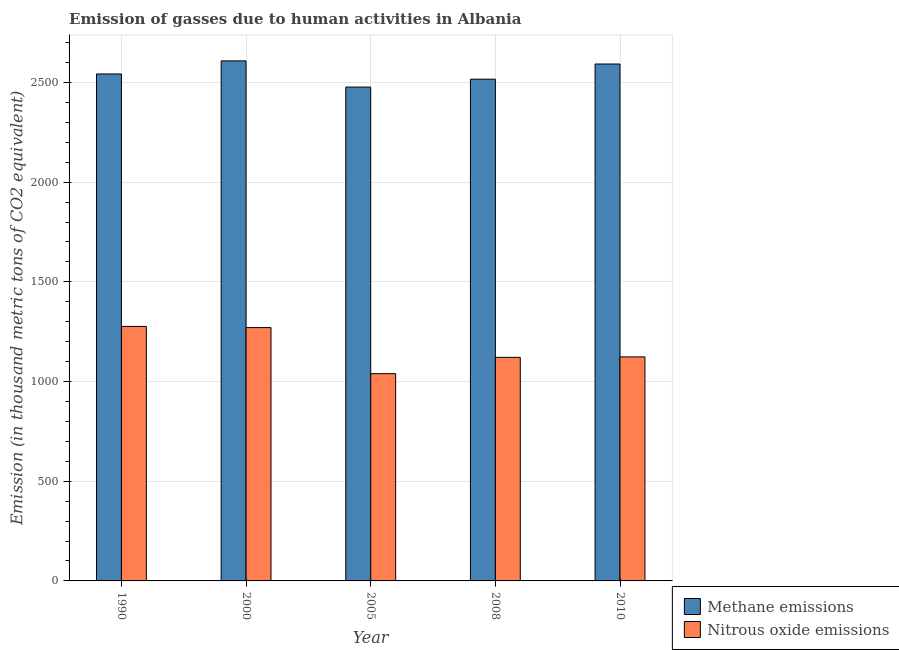How many different coloured bars are there?
Your answer should be very brief. 2. How many groups of bars are there?
Keep it short and to the point. 5. How many bars are there on the 3rd tick from the right?
Make the answer very short. 2. What is the label of the 5th group of bars from the left?
Provide a short and direct response. 2010. What is the amount of methane emissions in 2010?
Provide a succinct answer. 2592.7. Across all years, what is the maximum amount of nitrous oxide emissions?
Make the answer very short. 1276.4. Across all years, what is the minimum amount of methane emissions?
Offer a very short reply. 2477.1. In which year was the amount of methane emissions maximum?
Provide a short and direct response. 2000. In which year was the amount of methane emissions minimum?
Ensure brevity in your answer.  2005. What is the total amount of methane emissions in the graph?
Offer a terse response. 1.27e+04. What is the difference between the amount of methane emissions in 2005 and that in 2010?
Your answer should be very brief. -115.6. What is the difference between the amount of nitrous oxide emissions in 2000 and the amount of methane emissions in 2005?
Provide a succinct answer. 231.1. What is the average amount of nitrous oxide emissions per year?
Offer a very short reply. 1166.34. In the year 2008, what is the difference between the amount of methane emissions and amount of nitrous oxide emissions?
Offer a very short reply. 0. What is the ratio of the amount of nitrous oxide emissions in 1990 to that in 2010?
Ensure brevity in your answer.  1.14. Is the amount of nitrous oxide emissions in 2000 less than that in 2008?
Offer a very short reply. No. Is the difference between the amount of methane emissions in 2008 and 2010 greater than the difference between the amount of nitrous oxide emissions in 2008 and 2010?
Provide a short and direct response. No. What is the difference between the highest and the second highest amount of methane emissions?
Offer a very short reply. 15.7. What is the difference between the highest and the lowest amount of methane emissions?
Ensure brevity in your answer.  131.3. In how many years, is the amount of nitrous oxide emissions greater than the average amount of nitrous oxide emissions taken over all years?
Ensure brevity in your answer.  2. Is the sum of the amount of nitrous oxide emissions in 1990 and 2005 greater than the maximum amount of methane emissions across all years?
Offer a terse response. Yes. What does the 1st bar from the left in 1990 represents?
Ensure brevity in your answer.  Methane emissions. What does the 2nd bar from the right in 2010 represents?
Offer a terse response. Methane emissions. How many bars are there?
Give a very brief answer. 10. Are the values on the major ticks of Y-axis written in scientific E-notation?
Provide a succinct answer. No. Does the graph contain any zero values?
Your answer should be compact. No. Where does the legend appear in the graph?
Your answer should be compact. Bottom right. How many legend labels are there?
Ensure brevity in your answer.  2. What is the title of the graph?
Make the answer very short. Emission of gasses due to human activities in Albania. Does "Automatic Teller Machines" appear as one of the legend labels in the graph?
Offer a terse response. No. What is the label or title of the X-axis?
Keep it short and to the point. Year. What is the label or title of the Y-axis?
Provide a short and direct response. Emission (in thousand metric tons of CO2 equivalent). What is the Emission (in thousand metric tons of CO2 equivalent) in Methane emissions in 1990?
Offer a very short reply. 2542.8. What is the Emission (in thousand metric tons of CO2 equivalent) in Nitrous oxide emissions in 1990?
Your response must be concise. 1276.4. What is the Emission (in thousand metric tons of CO2 equivalent) of Methane emissions in 2000?
Your response must be concise. 2608.4. What is the Emission (in thousand metric tons of CO2 equivalent) of Nitrous oxide emissions in 2000?
Offer a terse response. 1270.7. What is the Emission (in thousand metric tons of CO2 equivalent) of Methane emissions in 2005?
Offer a terse response. 2477.1. What is the Emission (in thousand metric tons of CO2 equivalent) of Nitrous oxide emissions in 2005?
Provide a succinct answer. 1039.6. What is the Emission (in thousand metric tons of CO2 equivalent) of Methane emissions in 2008?
Your answer should be very brief. 2516.7. What is the Emission (in thousand metric tons of CO2 equivalent) of Nitrous oxide emissions in 2008?
Make the answer very short. 1121.4. What is the Emission (in thousand metric tons of CO2 equivalent) of Methane emissions in 2010?
Provide a short and direct response. 2592.7. What is the Emission (in thousand metric tons of CO2 equivalent) in Nitrous oxide emissions in 2010?
Your answer should be very brief. 1123.6. Across all years, what is the maximum Emission (in thousand metric tons of CO2 equivalent) in Methane emissions?
Your answer should be very brief. 2608.4. Across all years, what is the maximum Emission (in thousand metric tons of CO2 equivalent) in Nitrous oxide emissions?
Your answer should be very brief. 1276.4. Across all years, what is the minimum Emission (in thousand metric tons of CO2 equivalent) of Methane emissions?
Offer a terse response. 2477.1. Across all years, what is the minimum Emission (in thousand metric tons of CO2 equivalent) in Nitrous oxide emissions?
Your response must be concise. 1039.6. What is the total Emission (in thousand metric tons of CO2 equivalent) in Methane emissions in the graph?
Give a very brief answer. 1.27e+04. What is the total Emission (in thousand metric tons of CO2 equivalent) of Nitrous oxide emissions in the graph?
Your response must be concise. 5831.7. What is the difference between the Emission (in thousand metric tons of CO2 equivalent) in Methane emissions in 1990 and that in 2000?
Offer a very short reply. -65.6. What is the difference between the Emission (in thousand metric tons of CO2 equivalent) of Methane emissions in 1990 and that in 2005?
Your answer should be very brief. 65.7. What is the difference between the Emission (in thousand metric tons of CO2 equivalent) of Nitrous oxide emissions in 1990 and that in 2005?
Offer a terse response. 236.8. What is the difference between the Emission (in thousand metric tons of CO2 equivalent) in Methane emissions in 1990 and that in 2008?
Keep it short and to the point. 26.1. What is the difference between the Emission (in thousand metric tons of CO2 equivalent) in Nitrous oxide emissions in 1990 and that in 2008?
Ensure brevity in your answer.  155. What is the difference between the Emission (in thousand metric tons of CO2 equivalent) of Methane emissions in 1990 and that in 2010?
Offer a very short reply. -49.9. What is the difference between the Emission (in thousand metric tons of CO2 equivalent) in Nitrous oxide emissions in 1990 and that in 2010?
Your answer should be very brief. 152.8. What is the difference between the Emission (in thousand metric tons of CO2 equivalent) of Methane emissions in 2000 and that in 2005?
Your answer should be compact. 131.3. What is the difference between the Emission (in thousand metric tons of CO2 equivalent) of Nitrous oxide emissions in 2000 and that in 2005?
Keep it short and to the point. 231.1. What is the difference between the Emission (in thousand metric tons of CO2 equivalent) in Methane emissions in 2000 and that in 2008?
Your answer should be very brief. 91.7. What is the difference between the Emission (in thousand metric tons of CO2 equivalent) in Nitrous oxide emissions in 2000 and that in 2008?
Your response must be concise. 149.3. What is the difference between the Emission (in thousand metric tons of CO2 equivalent) of Methane emissions in 2000 and that in 2010?
Make the answer very short. 15.7. What is the difference between the Emission (in thousand metric tons of CO2 equivalent) in Nitrous oxide emissions in 2000 and that in 2010?
Offer a terse response. 147.1. What is the difference between the Emission (in thousand metric tons of CO2 equivalent) in Methane emissions in 2005 and that in 2008?
Offer a very short reply. -39.6. What is the difference between the Emission (in thousand metric tons of CO2 equivalent) of Nitrous oxide emissions in 2005 and that in 2008?
Your answer should be compact. -81.8. What is the difference between the Emission (in thousand metric tons of CO2 equivalent) of Methane emissions in 2005 and that in 2010?
Provide a succinct answer. -115.6. What is the difference between the Emission (in thousand metric tons of CO2 equivalent) of Nitrous oxide emissions in 2005 and that in 2010?
Ensure brevity in your answer.  -84. What is the difference between the Emission (in thousand metric tons of CO2 equivalent) of Methane emissions in 2008 and that in 2010?
Make the answer very short. -76. What is the difference between the Emission (in thousand metric tons of CO2 equivalent) in Nitrous oxide emissions in 2008 and that in 2010?
Provide a short and direct response. -2.2. What is the difference between the Emission (in thousand metric tons of CO2 equivalent) of Methane emissions in 1990 and the Emission (in thousand metric tons of CO2 equivalent) of Nitrous oxide emissions in 2000?
Your response must be concise. 1272.1. What is the difference between the Emission (in thousand metric tons of CO2 equivalent) in Methane emissions in 1990 and the Emission (in thousand metric tons of CO2 equivalent) in Nitrous oxide emissions in 2005?
Your answer should be compact. 1503.2. What is the difference between the Emission (in thousand metric tons of CO2 equivalent) of Methane emissions in 1990 and the Emission (in thousand metric tons of CO2 equivalent) of Nitrous oxide emissions in 2008?
Ensure brevity in your answer.  1421.4. What is the difference between the Emission (in thousand metric tons of CO2 equivalent) of Methane emissions in 1990 and the Emission (in thousand metric tons of CO2 equivalent) of Nitrous oxide emissions in 2010?
Your answer should be very brief. 1419.2. What is the difference between the Emission (in thousand metric tons of CO2 equivalent) of Methane emissions in 2000 and the Emission (in thousand metric tons of CO2 equivalent) of Nitrous oxide emissions in 2005?
Keep it short and to the point. 1568.8. What is the difference between the Emission (in thousand metric tons of CO2 equivalent) of Methane emissions in 2000 and the Emission (in thousand metric tons of CO2 equivalent) of Nitrous oxide emissions in 2008?
Your answer should be compact. 1487. What is the difference between the Emission (in thousand metric tons of CO2 equivalent) in Methane emissions in 2000 and the Emission (in thousand metric tons of CO2 equivalent) in Nitrous oxide emissions in 2010?
Your response must be concise. 1484.8. What is the difference between the Emission (in thousand metric tons of CO2 equivalent) of Methane emissions in 2005 and the Emission (in thousand metric tons of CO2 equivalent) of Nitrous oxide emissions in 2008?
Provide a succinct answer. 1355.7. What is the difference between the Emission (in thousand metric tons of CO2 equivalent) in Methane emissions in 2005 and the Emission (in thousand metric tons of CO2 equivalent) in Nitrous oxide emissions in 2010?
Provide a short and direct response. 1353.5. What is the difference between the Emission (in thousand metric tons of CO2 equivalent) in Methane emissions in 2008 and the Emission (in thousand metric tons of CO2 equivalent) in Nitrous oxide emissions in 2010?
Your answer should be compact. 1393.1. What is the average Emission (in thousand metric tons of CO2 equivalent) of Methane emissions per year?
Provide a short and direct response. 2547.54. What is the average Emission (in thousand metric tons of CO2 equivalent) in Nitrous oxide emissions per year?
Provide a short and direct response. 1166.34. In the year 1990, what is the difference between the Emission (in thousand metric tons of CO2 equivalent) in Methane emissions and Emission (in thousand metric tons of CO2 equivalent) in Nitrous oxide emissions?
Give a very brief answer. 1266.4. In the year 2000, what is the difference between the Emission (in thousand metric tons of CO2 equivalent) of Methane emissions and Emission (in thousand metric tons of CO2 equivalent) of Nitrous oxide emissions?
Provide a short and direct response. 1337.7. In the year 2005, what is the difference between the Emission (in thousand metric tons of CO2 equivalent) in Methane emissions and Emission (in thousand metric tons of CO2 equivalent) in Nitrous oxide emissions?
Provide a succinct answer. 1437.5. In the year 2008, what is the difference between the Emission (in thousand metric tons of CO2 equivalent) of Methane emissions and Emission (in thousand metric tons of CO2 equivalent) of Nitrous oxide emissions?
Your answer should be compact. 1395.3. In the year 2010, what is the difference between the Emission (in thousand metric tons of CO2 equivalent) of Methane emissions and Emission (in thousand metric tons of CO2 equivalent) of Nitrous oxide emissions?
Keep it short and to the point. 1469.1. What is the ratio of the Emission (in thousand metric tons of CO2 equivalent) in Methane emissions in 1990 to that in 2000?
Your answer should be compact. 0.97. What is the ratio of the Emission (in thousand metric tons of CO2 equivalent) in Methane emissions in 1990 to that in 2005?
Provide a short and direct response. 1.03. What is the ratio of the Emission (in thousand metric tons of CO2 equivalent) of Nitrous oxide emissions in 1990 to that in 2005?
Ensure brevity in your answer.  1.23. What is the ratio of the Emission (in thousand metric tons of CO2 equivalent) of Methane emissions in 1990 to that in 2008?
Provide a succinct answer. 1.01. What is the ratio of the Emission (in thousand metric tons of CO2 equivalent) in Nitrous oxide emissions in 1990 to that in 2008?
Provide a succinct answer. 1.14. What is the ratio of the Emission (in thousand metric tons of CO2 equivalent) of Methane emissions in 1990 to that in 2010?
Ensure brevity in your answer.  0.98. What is the ratio of the Emission (in thousand metric tons of CO2 equivalent) in Nitrous oxide emissions in 1990 to that in 2010?
Give a very brief answer. 1.14. What is the ratio of the Emission (in thousand metric tons of CO2 equivalent) of Methane emissions in 2000 to that in 2005?
Give a very brief answer. 1.05. What is the ratio of the Emission (in thousand metric tons of CO2 equivalent) of Nitrous oxide emissions in 2000 to that in 2005?
Offer a terse response. 1.22. What is the ratio of the Emission (in thousand metric tons of CO2 equivalent) in Methane emissions in 2000 to that in 2008?
Provide a succinct answer. 1.04. What is the ratio of the Emission (in thousand metric tons of CO2 equivalent) in Nitrous oxide emissions in 2000 to that in 2008?
Ensure brevity in your answer.  1.13. What is the ratio of the Emission (in thousand metric tons of CO2 equivalent) of Methane emissions in 2000 to that in 2010?
Your answer should be compact. 1.01. What is the ratio of the Emission (in thousand metric tons of CO2 equivalent) in Nitrous oxide emissions in 2000 to that in 2010?
Provide a short and direct response. 1.13. What is the ratio of the Emission (in thousand metric tons of CO2 equivalent) of Methane emissions in 2005 to that in 2008?
Your answer should be compact. 0.98. What is the ratio of the Emission (in thousand metric tons of CO2 equivalent) of Nitrous oxide emissions in 2005 to that in 2008?
Make the answer very short. 0.93. What is the ratio of the Emission (in thousand metric tons of CO2 equivalent) in Methane emissions in 2005 to that in 2010?
Give a very brief answer. 0.96. What is the ratio of the Emission (in thousand metric tons of CO2 equivalent) in Nitrous oxide emissions in 2005 to that in 2010?
Provide a succinct answer. 0.93. What is the ratio of the Emission (in thousand metric tons of CO2 equivalent) in Methane emissions in 2008 to that in 2010?
Provide a succinct answer. 0.97. What is the ratio of the Emission (in thousand metric tons of CO2 equivalent) in Nitrous oxide emissions in 2008 to that in 2010?
Give a very brief answer. 1. What is the difference between the highest and the lowest Emission (in thousand metric tons of CO2 equivalent) of Methane emissions?
Offer a very short reply. 131.3. What is the difference between the highest and the lowest Emission (in thousand metric tons of CO2 equivalent) in Nitrous oxide emissions?
Provide a short and direct response. 236.8. 